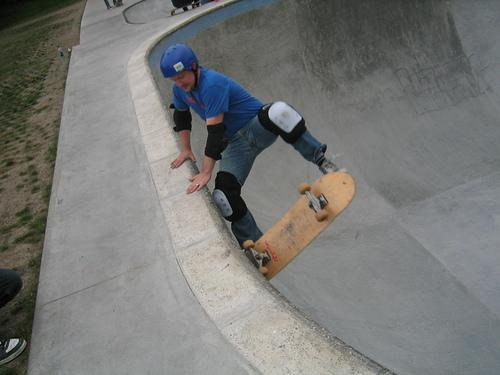What is the area the man is skating in usually called? Please explain your reasoning. bowl. Empty pools and purpose-built skateparks are called bowls for their shape. 